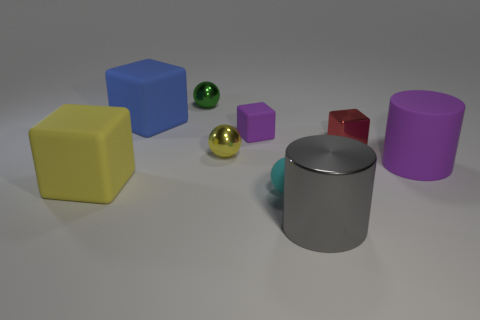Subtract all purple cubes. How many cubes are left? 3 Subtract all yellow blocks. How many blocks are left? 3 Add 1 large gray cylinders. How many objects exist? 10 Subtract all brown blocks. Subtract all blue balls. How many blocks are left? 4 Subtract all cylinders. How many objects are left? 7 Subtract all tiny red shiny cylinders. Subtract all cyan matte objects. How many objects are left? 8 Add 2 big matte cylinders. How many big matte cylinders are left? 3 Add 2 tiny cyan rubber balls. How many tiny cyan rubber balls exist? 3 Subtract 1 yellow balls. How many objects are left? 8 